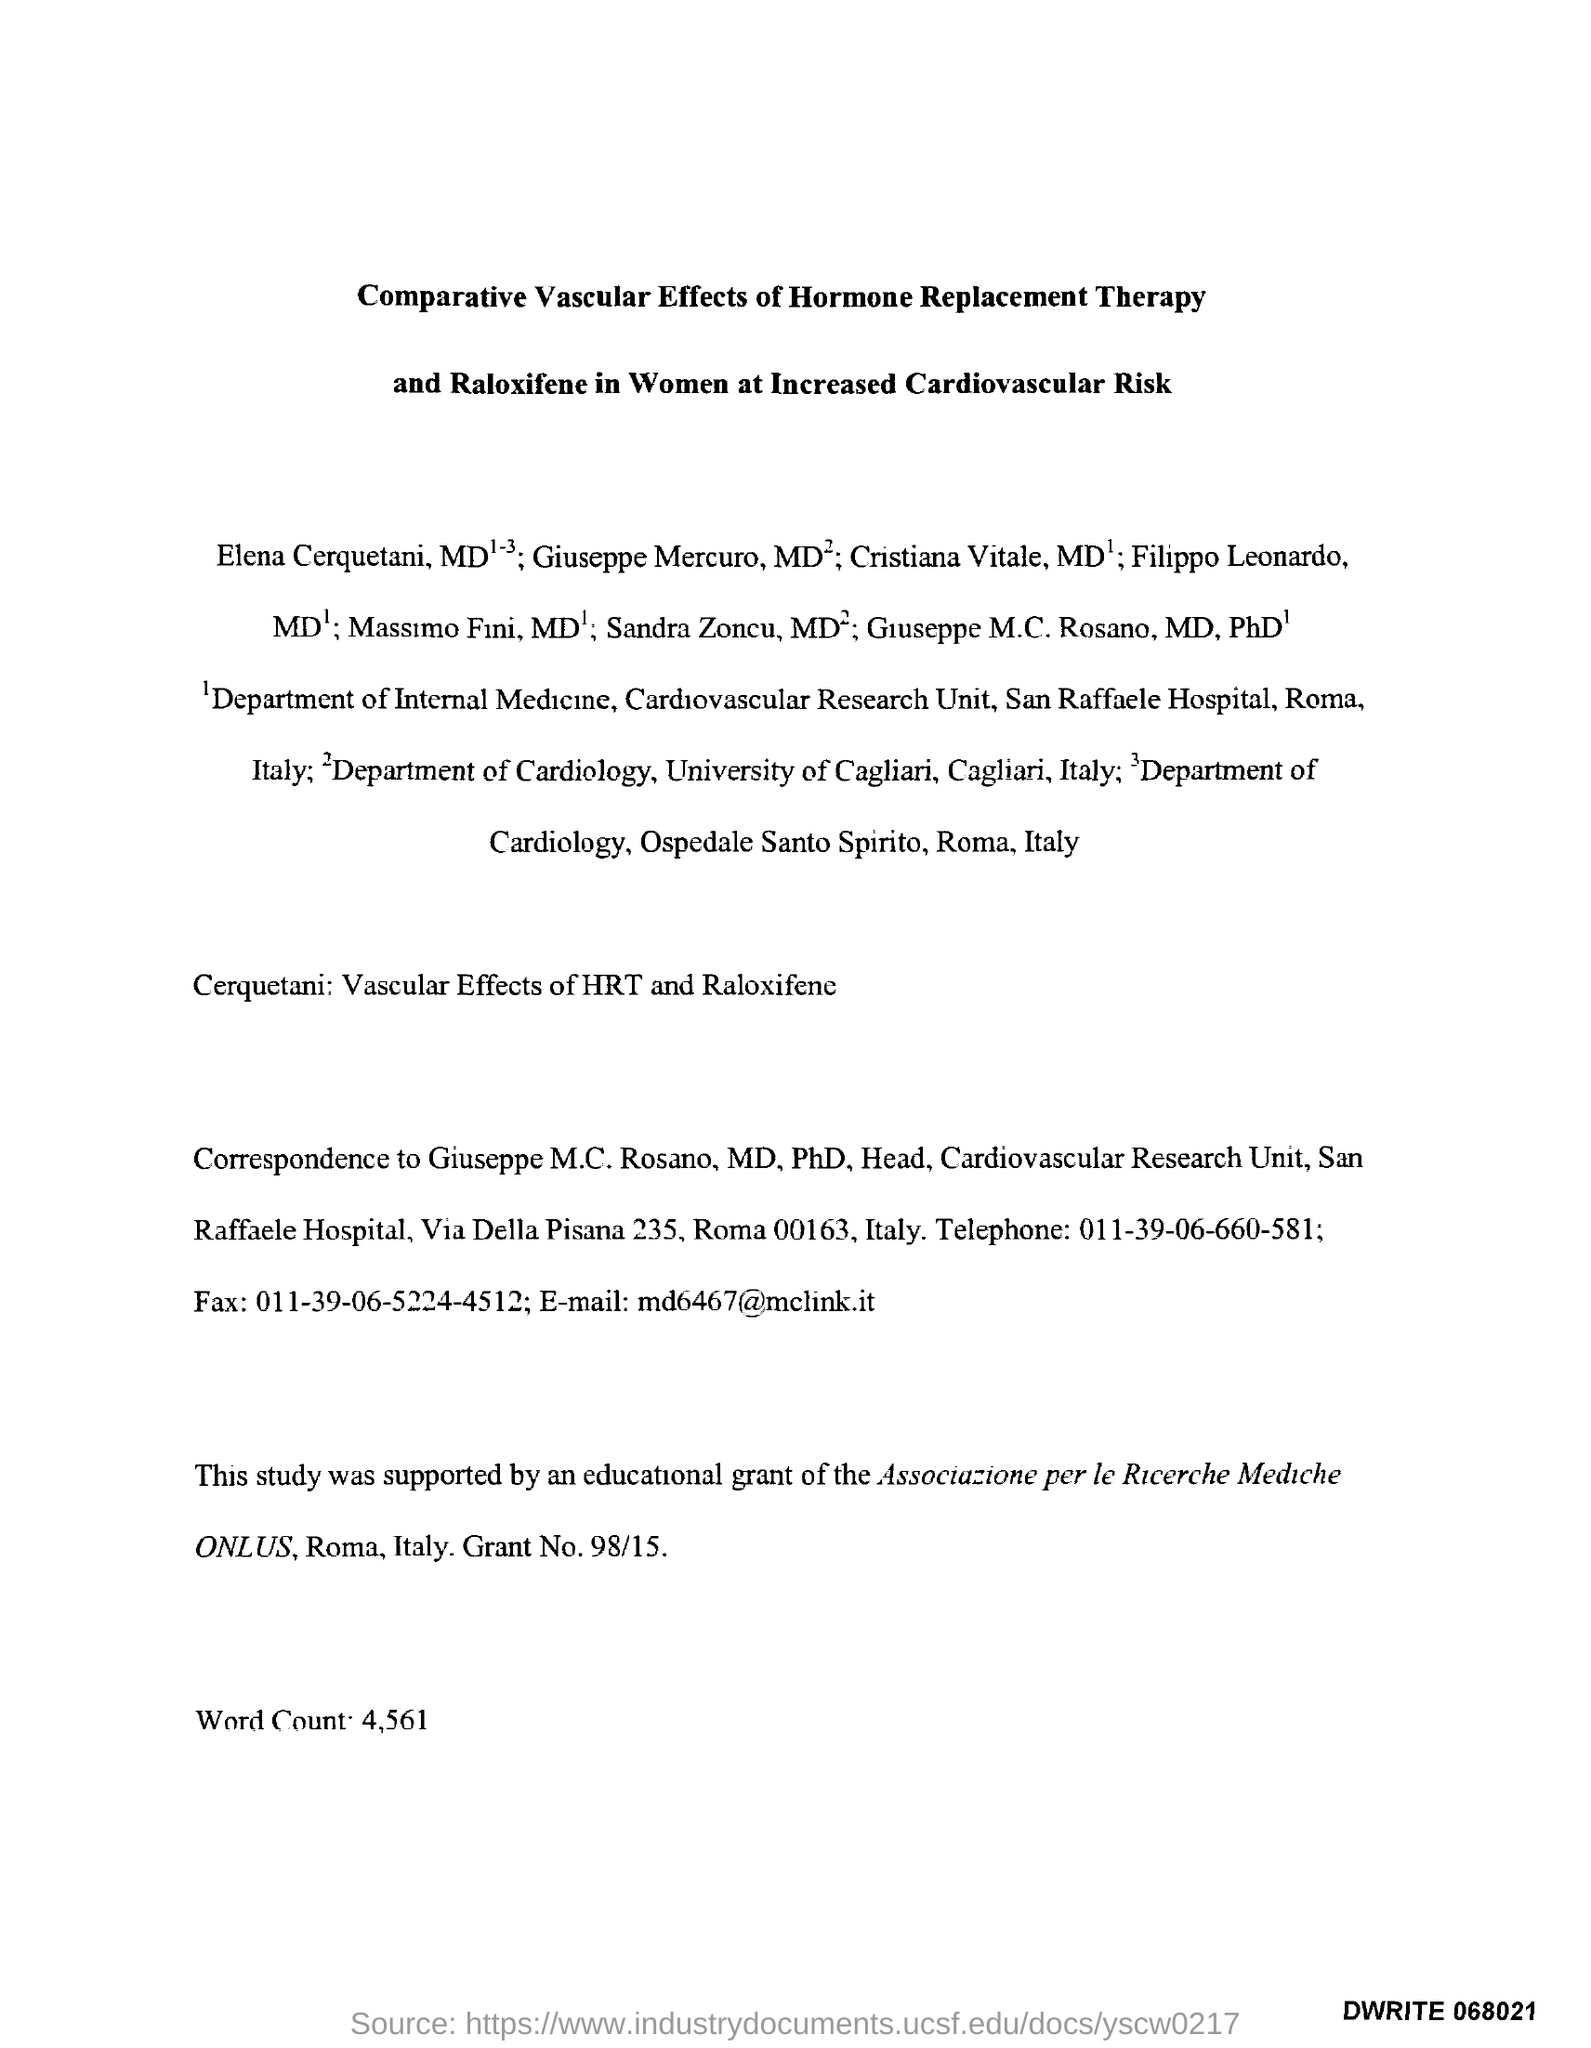Mention a couple of crucial points in this snapshot. The grant number is 98/15. The telephone number is 011-39-06-660-581. The word count is 4,561. The fax number is 011-39-06-5224-4512. The email address is "[md6467@mclink.it](mailto:md6467@mclink.it). 